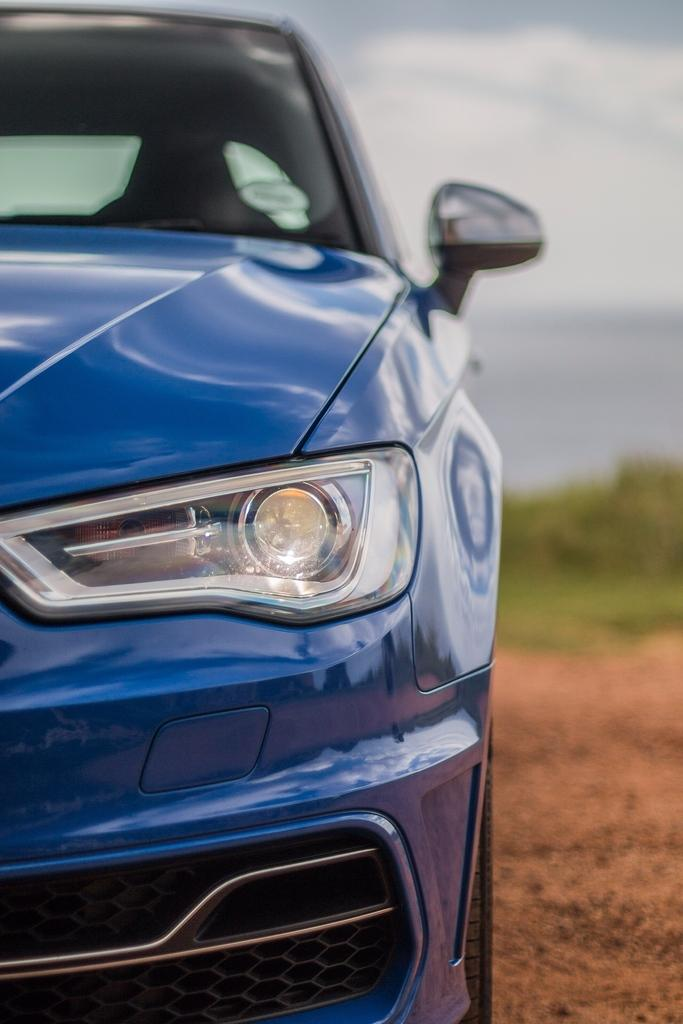What is the main subject of the image? The main subject of the image is a car. Where is the car located in the image? The car is on the ground in the image. What can be seen in the background of the image? There is grass and the sky visible in the background of the image. What is the condition of the sky in the image? The sky has clouds present in it. What type of protest is happening in the image? There is no protest present in the image; it features a car on the ground with grass and a cloudy sky in the background. What kind of structure can be seen in the image? There is no structure present in the image; it only features a car, grass, and the sky. 